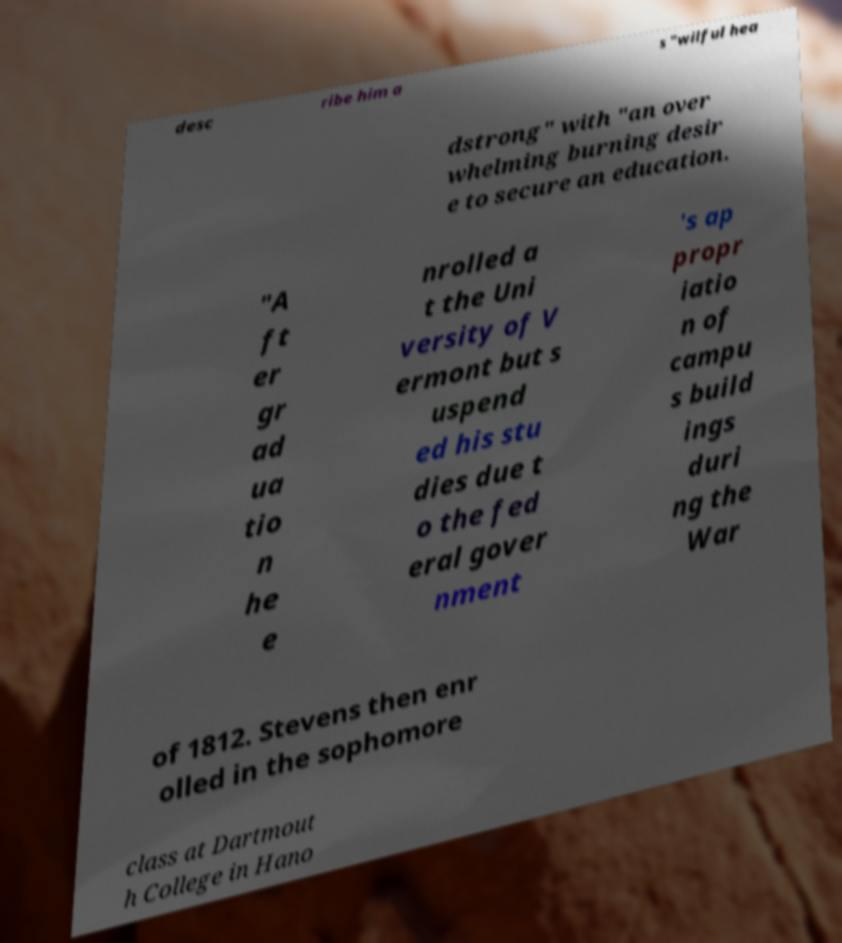Could you extract and type out the text from this image? desc ribe him a s "wilful hea dstrong" with "an over whelming burning desir e to secure an education. "A ft er gr ad ua tio n he e nrolled a t the Uni versity of V ermont but s uspend ed his stu dies due t o the fed eral gover nment 's ap propr iatio n of campu s build ings duri ng the War of 1812. Stevens then enr olled in the sophomore class at Dartmout h College in Hano 